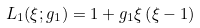Convert formula to latex. <formula><loc_0><loc_0><loc_500><loc_500>L _ { 1 } ( \xi ; g _ { 1 } ) = 1 + g _ { 1 } \xi \left ( \xi - 1 \right )</formula> 